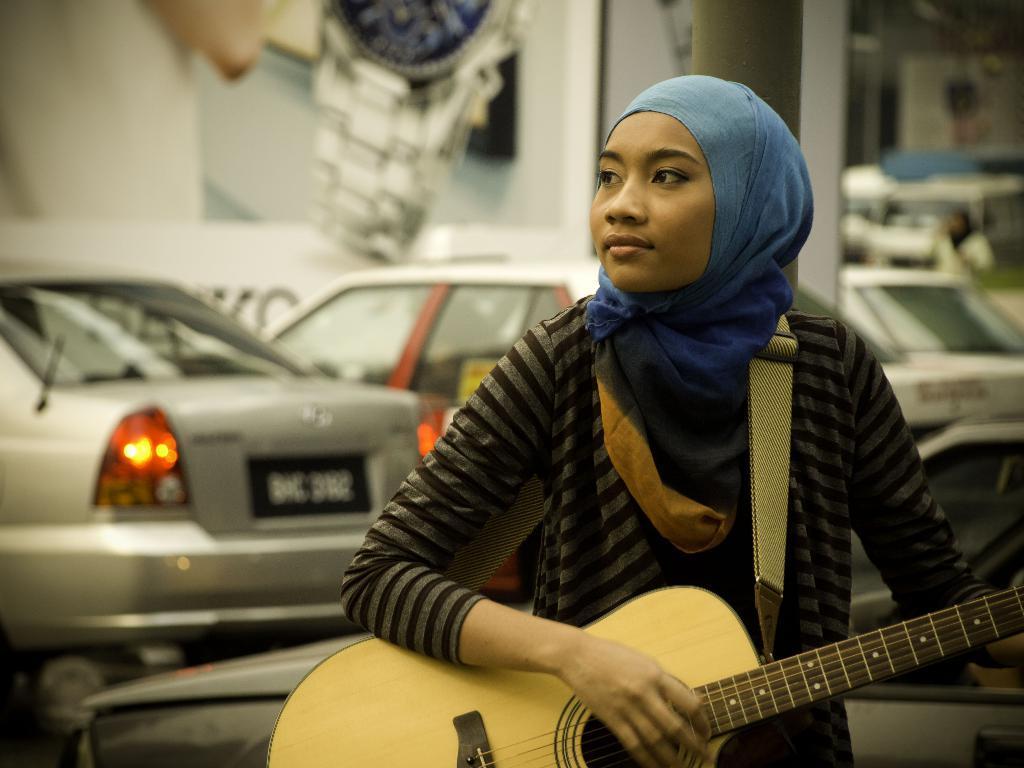How would you summarize this image in a sentence or two? In this image I can see a person holding the guitar. In the background there are cars. 